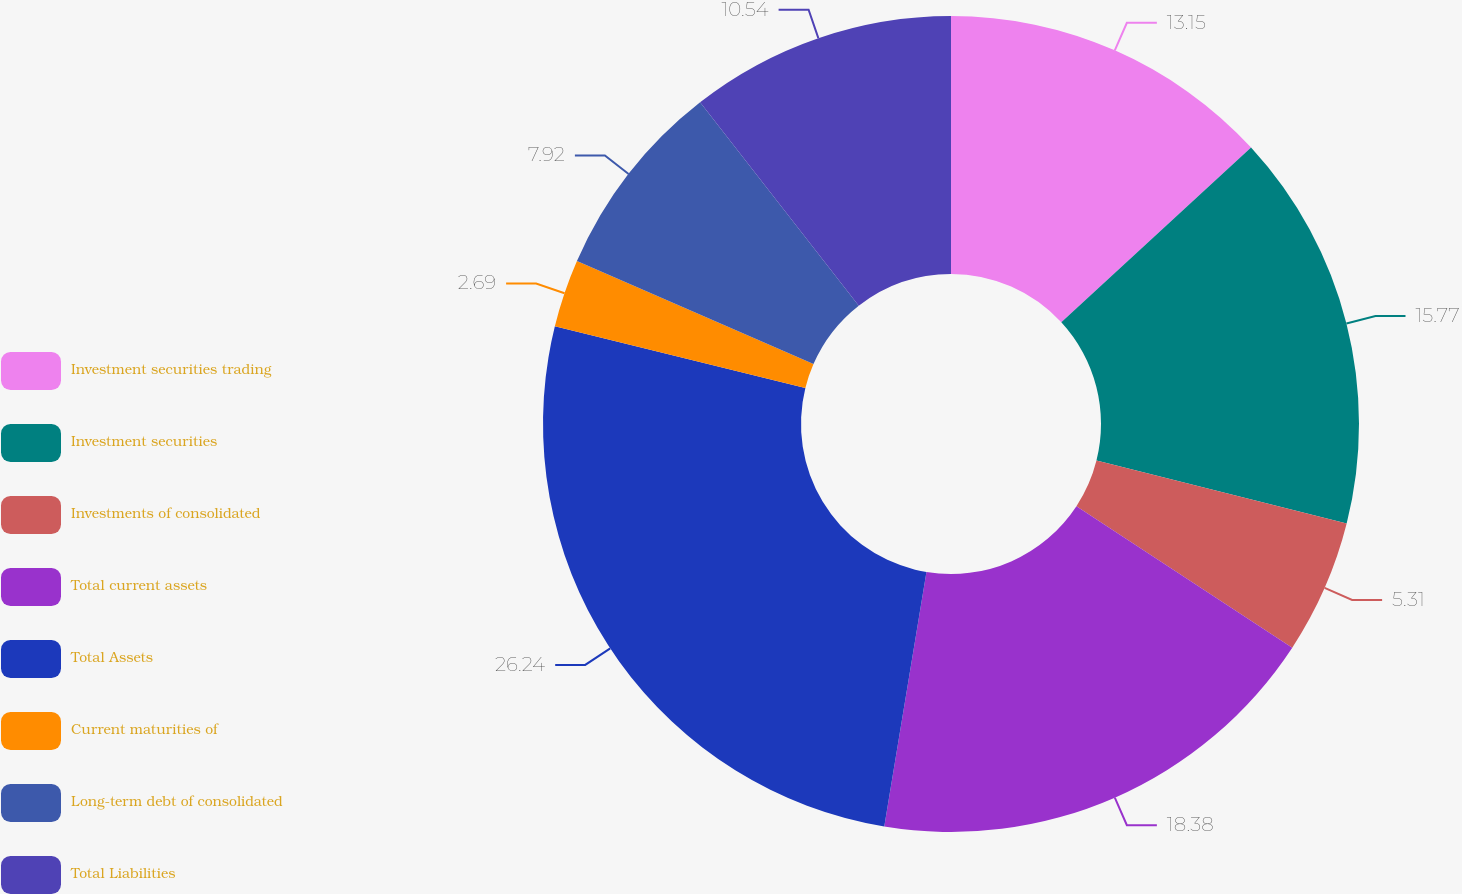Convert chart. <chart><loc_0><loc_0><loc_500><loc_500><pie_chart><fcel>Investment securities trading<fcel>Investment securities<fcel>Investments of consolidated<fcel>Total current assets<fcel>Total Assets<fcel>Current maturities of<fcel>Long-term debt of consolidated<fcel>Total Liabilities<nl><fcel>13.15%<fcel>15.77%<fcel>5.31%<fcel>18.38%<fcel>26.23%<fcel>2.69%<fcel>7.92%<fcel>10.54%<nl></chart> 